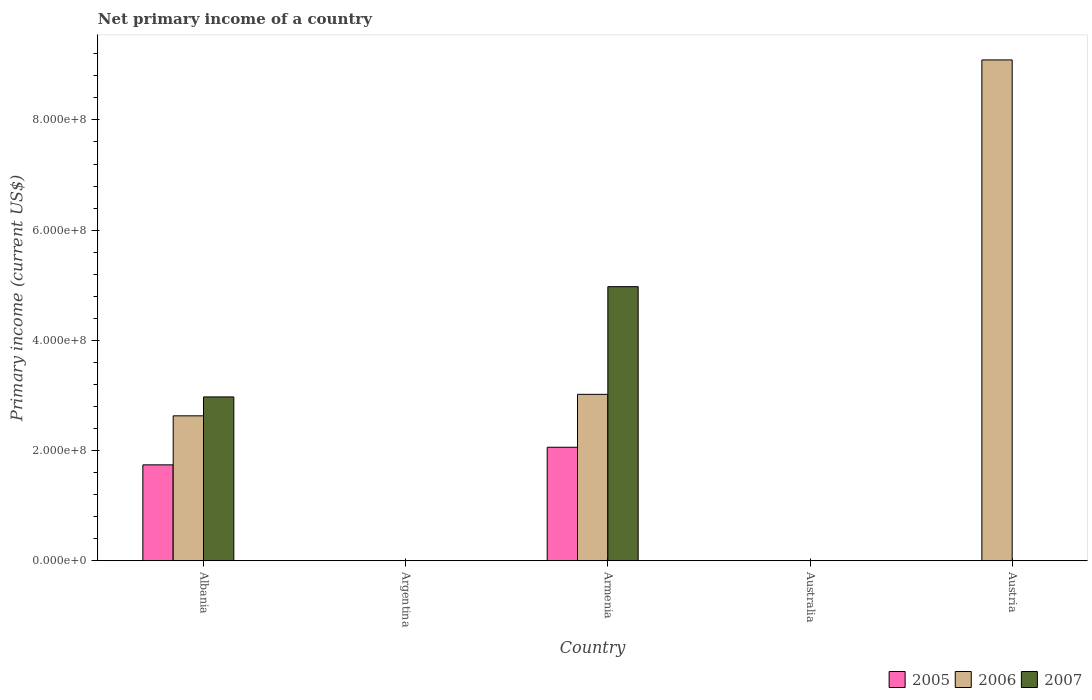Are the number of bars on each tick of the X-axis equal?
Keep it short and to the point. No. How many bars are there on the 5th tick from the left?
Your answer should be compact. 1. What is the primary income in 2005 in Australia?
Your response must be concise. 0. Across all countries, what is the maximum primary income in 2007?
Make the answer very short. 4.97e+08. In which country was the primary income in 2005 maximum?
Your answer should be very brief. Armenia. What is the total primary income in 2005 in the graph?
Give a very brief answer. 3.80e+08. What is the difference between the primary income in 2005 in Albania and that in Armenia?
Offer a terse response. -3.19e+07. What is the difference between the primary income in 2005 in Albania and the primary income in 2007 in Argentina?
Offer a very short reply. 1.74e+08. What is the average primary income in 2005 per country?
Offer a terse response. 7.60e+07. What is the difference between the primary income of/in 2006 and primary income of/in 2005 in Albania?
Give a very brief answer. 8.90e+07. Is the primary income in 2006 in Albania less than that in Austria?
Give a very brief answer. Yes. What is the difference between the highest and the second highest primary income in 2006?
Provide a succinct answer. -3.90e+07. What is the difference between the highest and the lowest primary income in 2006?
Keep it short and to the point. 9.09e+08. Are all the bars in the graph horizontal?
Give a very brief answer. No. What is the difference between two consecutive major ticks on the Y-axis?
Your answer should be very brief. 2.00e+08. Does the graph contain any zero values?
Your answer should be very brief. Yes. How are the legend labels stacked?
Keep it short and to the point. Horizontal. What is the title of the graph?
Ensure brevity in your answer.  Net primary income of a country. What is the label or title of the Y-axis?
Your response must be concise. Primary income (current US$). What is the Primary income (current US$) in 2005 in Albania?
Your answer should be very brief. 1.74e+08. What is the Primary income (current US$) of 2006 in Albania?
Make the answer very short. 2.63e+08. What is the Primary income (current US$) of 2007 in Albania?
Provide a short and direct response. 2.97e+08. What is the Primary income (current US$) of 2005 in Argentina?
Ensure brevity in your answer.  0. What is the Primary income (current US$) of 2005 in Armenia?
Ensure brevity in your answer.  2.06e+08. What is the Primary income (current US$) in 2006 in Armenia?
Your answer should be very brief. 3.02e+08. What is the Primary income (current US$) of 2007 in Armenia?
Offer a terse response. 4.97e+08. What is the Primary income (current US$) of 2006 in Australia?
Give a very brief answer. 0. What is the Primary income (current US$) in 2007 in Australia?
Ensure brevity in your answer.  0. What is the Primary income (current US$) in 2006 in Austria?
Offer a very short reply. 9.09e+08. Across all countries, what is the maximum Primary income (current US$) in 2005?
Give a very brief answer. 2.06e+08. Across all countries, what is the maximum Primary income (current US$) in 2006?
Make the answer very short. 9.09e+08. Across all countries, what is the maximum Primary income (current US$) of 2007?
Your answer should be compact. 4.97e+08. Across all countries, what is the minimum Primary income (current US$) in 2005?
Make the answer very short. 0. Across all countries, what is the minimum Primary income (current US$) of 2006?
Your response must be concise. 0. Across all countries, what is the minimum Primary income (current US$) in 2007?
Your answer should be very brief. 0. What is the total Primary income (current US$) of 2005 in the graph?
Give a very brief answer. 3.80e+08. What is the total Primary income (current US$) in 2006 in the graph?
Your answer should be very brief. 1.47e+09. What is the total Primary income (current US$) in 2007 in the graph?
Give a very brief answer. 7.95e+08. What is the difference between the Primary income (current US$) of 2005 in Albania and that in Armenia?
Ensure brevity in your answer.  -3.19e+07. What is the difference between the Primary income (current US$) in 2006 in Albania and that in Armenia?
Provide a short and direct response. -3.90e+07. What is the difference between the Primary income (current US$) of 2007 in Albania and that in Armenia?
Provide a short and direct response. -2.00e+08. What is the difference between the Primary income (current US$) of 2006 in Albania and that in Austria?
Ensure brevity in your answer.  -6.46e+08. What is the difference between the Primary income (current US$) of 2006 in Armenia and that in Austria?
Your response must be concise. -6.07e+08. What is the difference between the Primary income (current US$) of 2005 in Albania and the Primary income (current US$) of 2006 in Armenia?
Give a very brief answer. -1.28e+08. What is the difference between the Primary income (current US$) in 2005 in Albania and the Primary income (current US$) in 2007 in Armenia?
Keep it short and to the point. -3.23e+08. What is the difference between the Primary income (current US$) in 2006 in Albania and the Primary income (current US$) in 2007 in Armenia?
Keep it short and to the point. -2.34e+08. What is the difference between the Primary income (current US$) of 2005 in Albania and the Primary income (current US$) of 2006 in Austria?
Your answer should be very brief. -7.35e+08. What is the difference between the Primary income (current US$) of 2005 in Armenia and the Primary income (current US$) of 2006 in Austria?
Your answer should be compact. -7.03e+08. What is the average Primary income (current US$) in 2005 per country?
Give a very brief answer. 7.60e+07. What is the average Primary income (current US$) in 2006 per country?
Give a very brief answer. 2.95e+08. What is the average Primary income (current US$) in 2007 per country?
Offer a terse response. 1.59e+08. What is the difference between the Primary income (current US$) in 2005 and Primary income (current US$) in 2006 in Albania?
Your answer should be compact. -8.90e+07. What is the difference between the Primary income (current US$) of 2005 and Primary income (current US$) of 2007 in Albania?
Give a very brief answer. -1.23e+08. What is the difference between the Primary income (current US$) of 2006 and Primary income (current US$) of 2007 in Albania?
Ensure brevity in your answer.  -3.43e+07. What is the difference between the Primary income (current US$) in 2005 and Primary income (current US$) in 2006 in Armenia?
Give a very brief answer. -9.60e+07. What is the difference between the Primary income (current US$) of 2005 and Primary income (current US$) of 2007 in Armenia?
Keep it short and to the point. -2.91e+08. What is the difference between the Primary income (current US$) of 2006 and Primary income (current US$) of 2007 in Armenia?
Make the answer very short. -1.95e+08. What is the ratio of the Primary income (current US$) in 2005 in Albania to that in Armenia?
Make the answer very short. 0.84. What is the ratio of the Primary income (current US$) of 2006 in Albania to that in Armenia?
Your response must be concise. 0.87. What is the ratio of the Primary income (current US$) in 2007 in Albania to that in Armenia?
Make the answer very short. 0.6. What is the ratio of the Primary income (current US$) in 2006 in Albania to that in Austria?
Provide a succinct answer. 0.29. What is the ratio of the Primary income (current US$) in 2006 in Armenia to that in Austria?
Offer a very short reply. 0.33. What is the difference between the highest and the second highest Primary income (current US$) in 2006?
Your answer should be compact. 6.07e+08. What is the difference between the highest and the lowest Primary income (current US$) of 2005?
Your answer should be compact. 2.06e+08. What is the difference between the highest and the lowest Primary income (current US$) of 2006?
Your answer should be very brief. 9.09e+08. What is the difference between the highest and the lowest Primary income (current US$) of 2007?
Keep it short and to the point. 4.97e+08. 